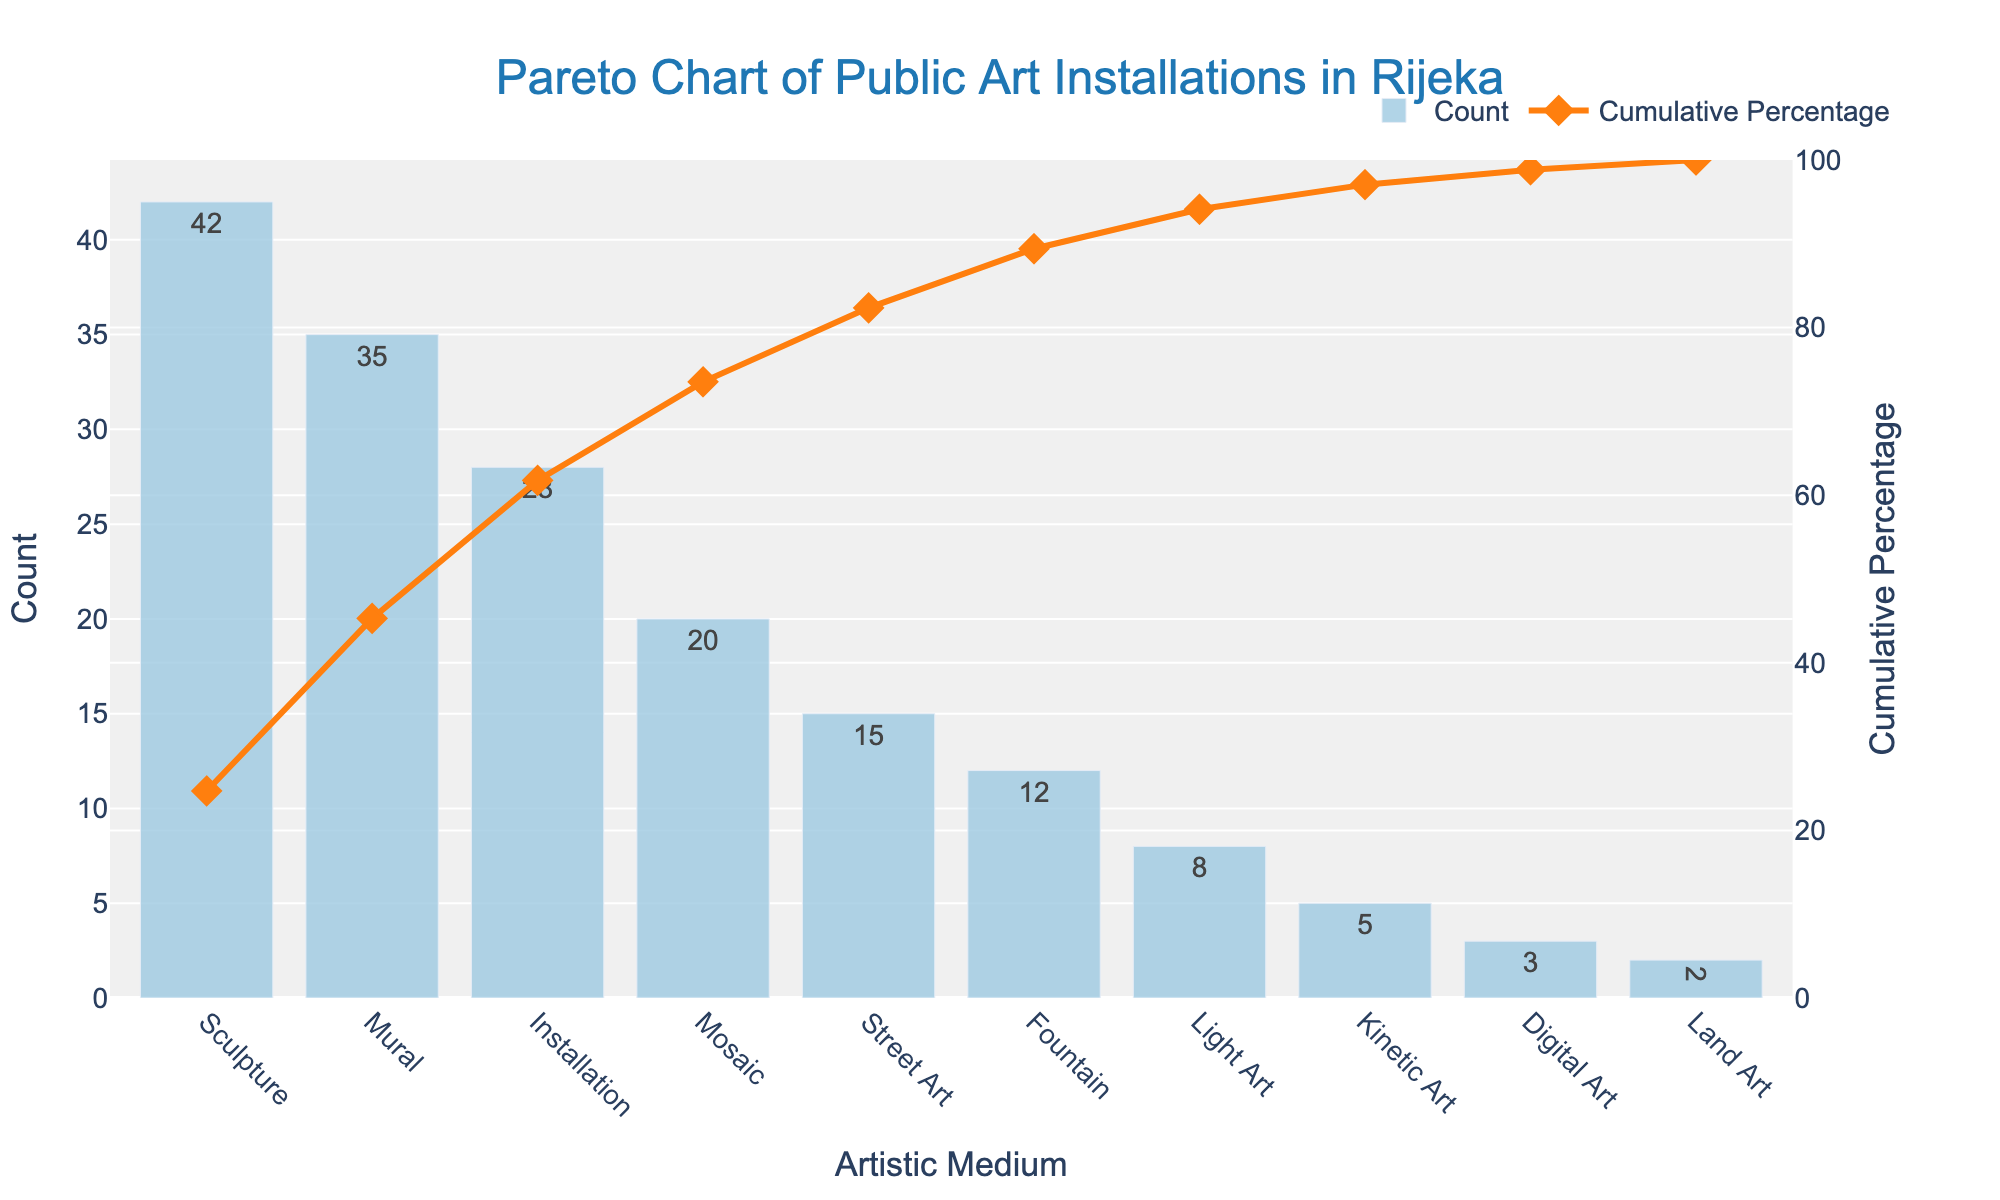Which medium has the highest count of public art installations? The Pareto chart shows bars representing the count of each artistic medium, with Sculpture having the tallest bar.
Answer: Sculpture What is the cumulative percentage for Murals? The line and markers representing the cumulative percentage indicate that for Murals, the cumulative percentage is just above 50%.
Answer: Just above 50% How many public art installations are categorized as Light Art? The bar for Light Art has a count that is shown as the text on the bar itself, which is 8.
Answer: 8 What is the total count of public art installations for the top three mediums? Adding the counts for Sculpture (42), Mural (35), and Installation (28), the total is 42 + 35 + 28 = 105.
Answer: 105 What percentage of the total installations do the top two mediums represent? The cumulative percentage for Installation (the third highest) tells us the top three make up nearly 64%. For the top two (Sculpture and Mural), remove Installation's percentage: approx 64% - 18% for Installation ≈ 46%.
Answer: Approximately 46% Which medium ranks fifth in terms of count, and what is its count? By checking the heights of the bars from left to right, Street Art stands fifth with a count of 15.
Answer: Street Art, 15 What cumulative percentage does the count of Installations represent? The cumulative percentage for Installations, found on the line plot, is around 64%.
Answer: Around 64% How much lower is the count of Kinetic Art compared to Mosaic? Mosaic has a count of 20, and Kinetic Art has a count of 5. The difference is 20 - 5 = 15.
Answer: 15 Compare the count of Digital Art and Land Art. Which is higher? By comparing the heights of their respective bars, Digital Art has a count of 3 and Land Art has a count of 2, making Digital Art higher by 1.
Answer: Digital Art 